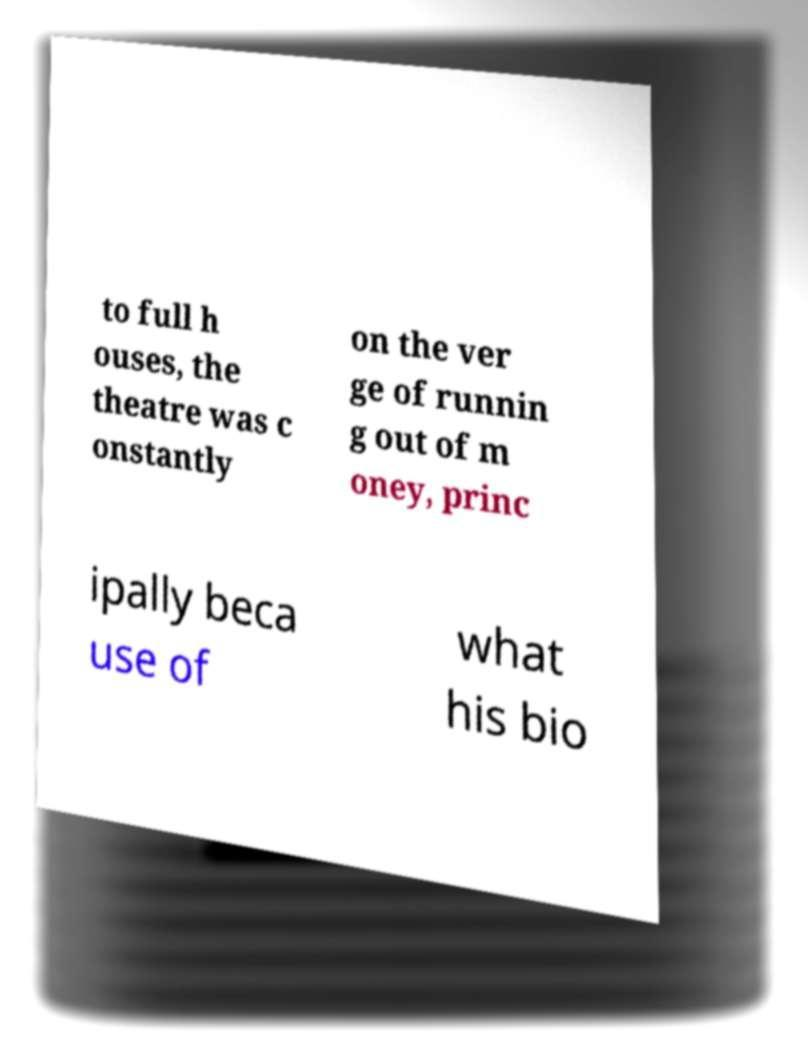There's text embedded in this image that I need extracted. Can you transcribe it verbatim? to full h ouses, the theatre was c onstantly on the ver ge of runnin g out of m oney, princ ipally beca use of what his bio 